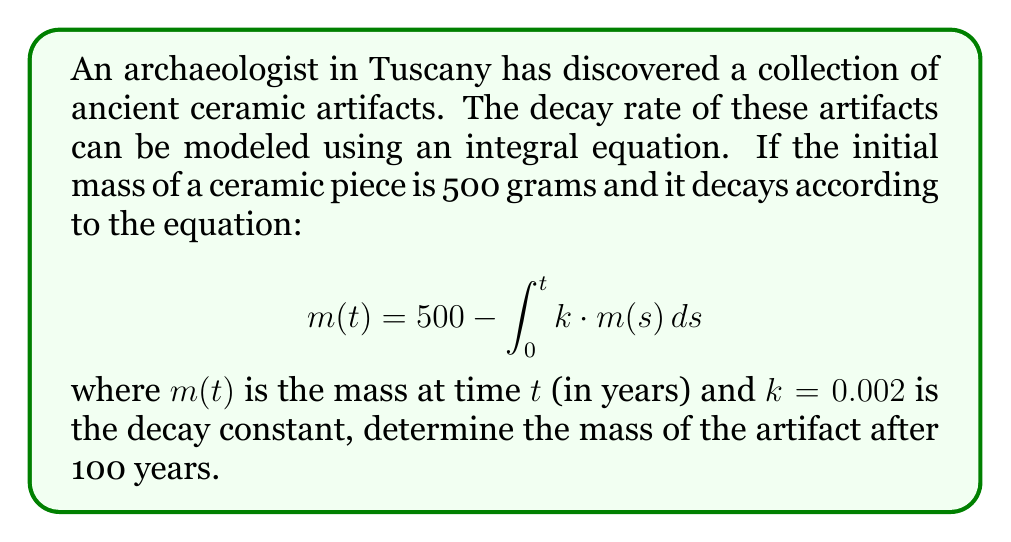Give your solution to this math problem. To solve this integral equation, we'll follow these steps:

1) First, we recognize this as a Volterra integral equation of the second kind.

2) We can solve this using the method of successive approximations (Picard iteration).

3) Let's start with the initial approximation $m_0(t) = 500$ (the initial mass).

4) Now, we substitute this into the right side of the equation to get the next approximation:

   $$m_1(t) = 500 - \int_0^t 0.002 \cdot 500 \, ds = 500 - 1t$$

5) We repeat this process:

   $$m_2(t) = 500 - \int_0^t 0.002 \cdot (500 - s) \, ds = 500 - t + 0.001t^2$$

6) Continuing this process, we get:

   $$m_3(t) = 500 - t + 0.001t^2 - \frac{1}{3000}t^3$$

7) As we continue this process, we approach the exact solution:

   $$m(t) = 500e^{-0.002t}$$

8) Now, we can calculate the mass after 100 years:

   $$m(100) = 500e^{-0.002 \cdot 100} = 500e^{-0.2} \approx 409.36$$

Therefore, after 100 years, the mass of the artifact will be approximately 409.36 grams.
Answer: $409.36$ grams 